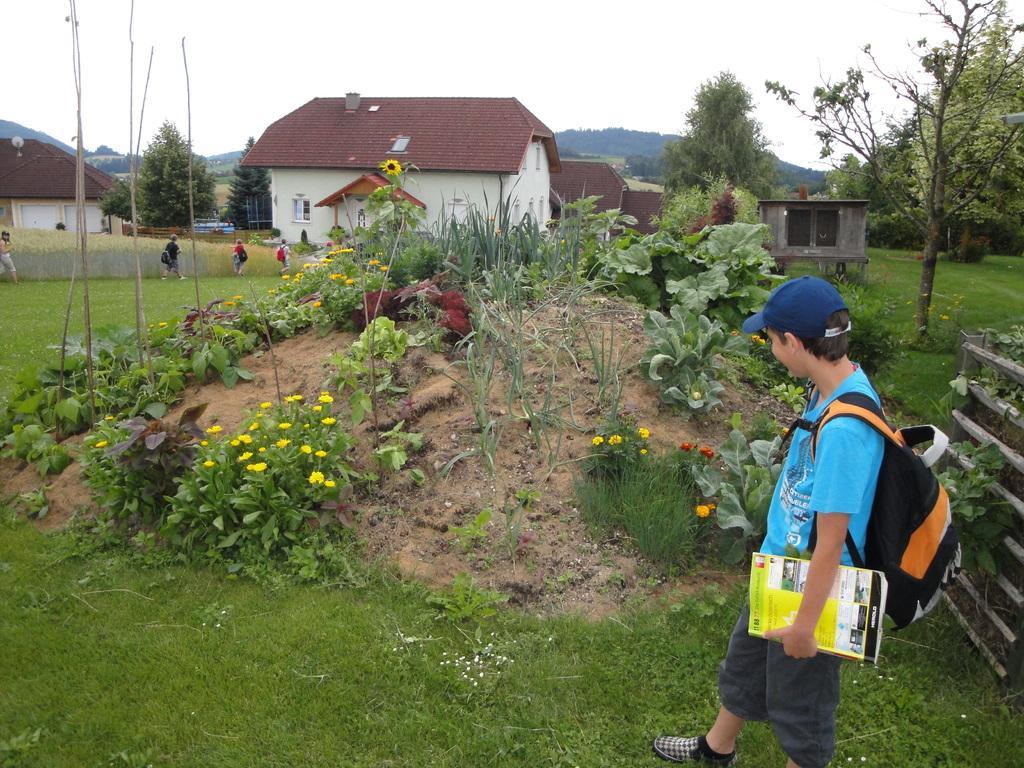In one or two sentences, can you explain what this image depicts? In this image I can see a person carrying a bag and holding a book. I can see the grass. I can see the flowers on the plants. In the background, I can see the houses, trees and the sky. 